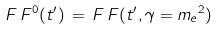<formula> <loc_0><loc_0><loc_500><loc_500>\, F \, F ^ { 0 } ( t ^ { \prime } ) \, = \, F \, F ( t ^ { \prime } , \gamma = { m _ { e } } ^ { 2 } ) \,</formula> 